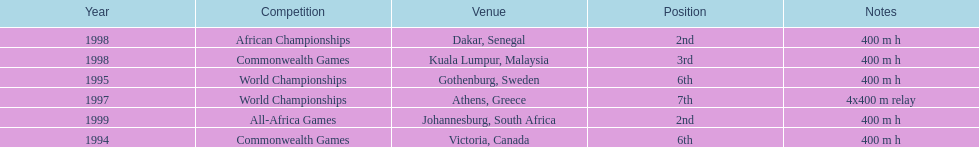What is the number of titles ken harden has one 6. 